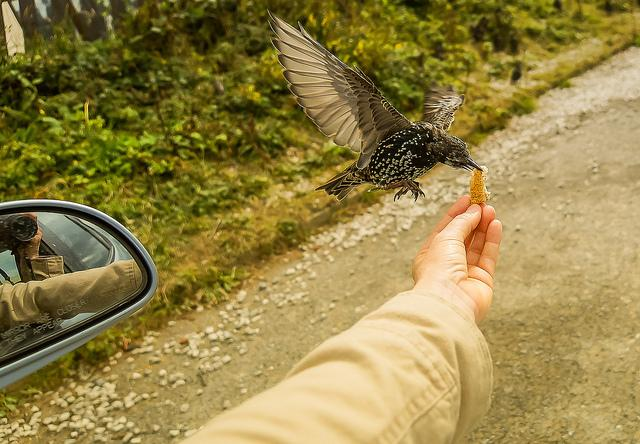What is the man doing to the bird?

Choices:
A) injuring it
B) feeding it
C) capturing it
D) hunting it feeding it 